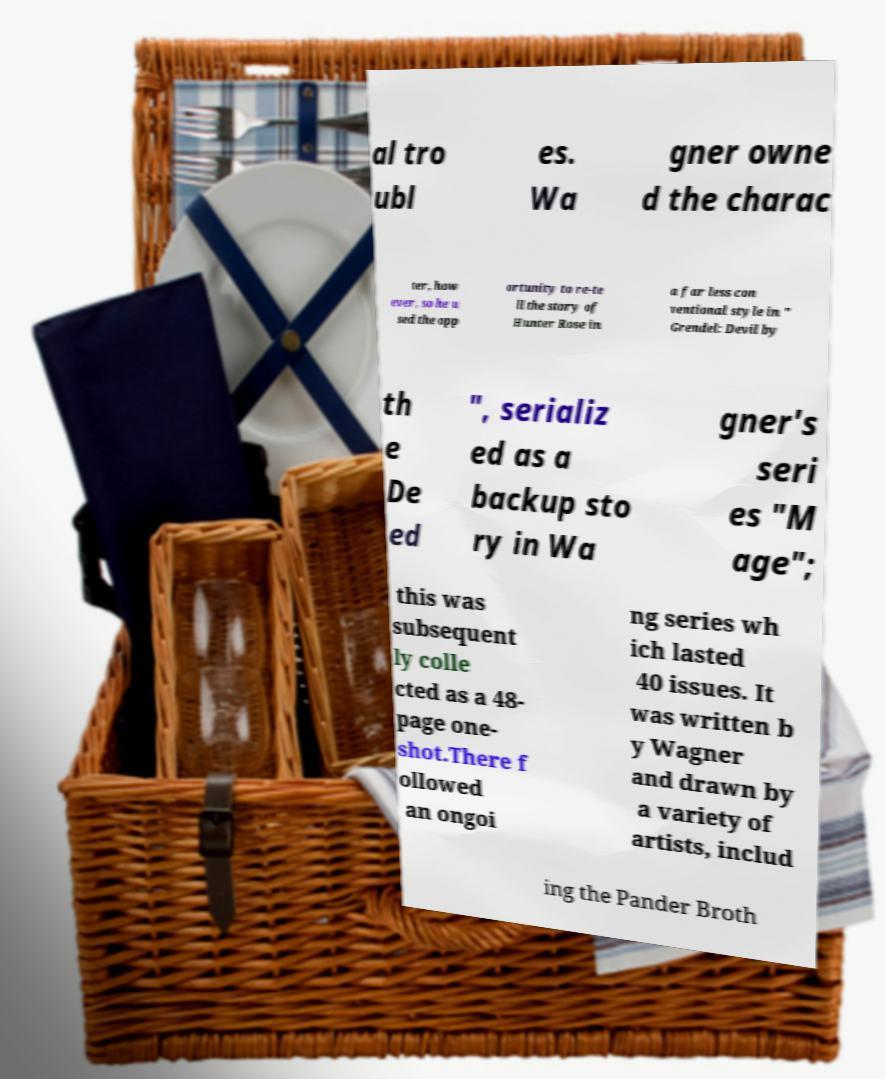I need the written content from this picture converted into text. Can you do that? al tro ubl es. Wa gner owne d the charac ter, how ever, so he u sed the opp ortunity to re-te ll the story of Hunter Rose in a far less con ventional style in " Grendel: Devil by th e De ed ", serializ ed as a backup sto ry in Wa gner's seri es "M age"; this was subsequent ly colle cted as a 48- page one- shot.There f ollowed an ongoi ng series wh ich lasted 40 issues. It was written b y Wagner and drawn by a variety of artists, includ ing the Pander Broth 